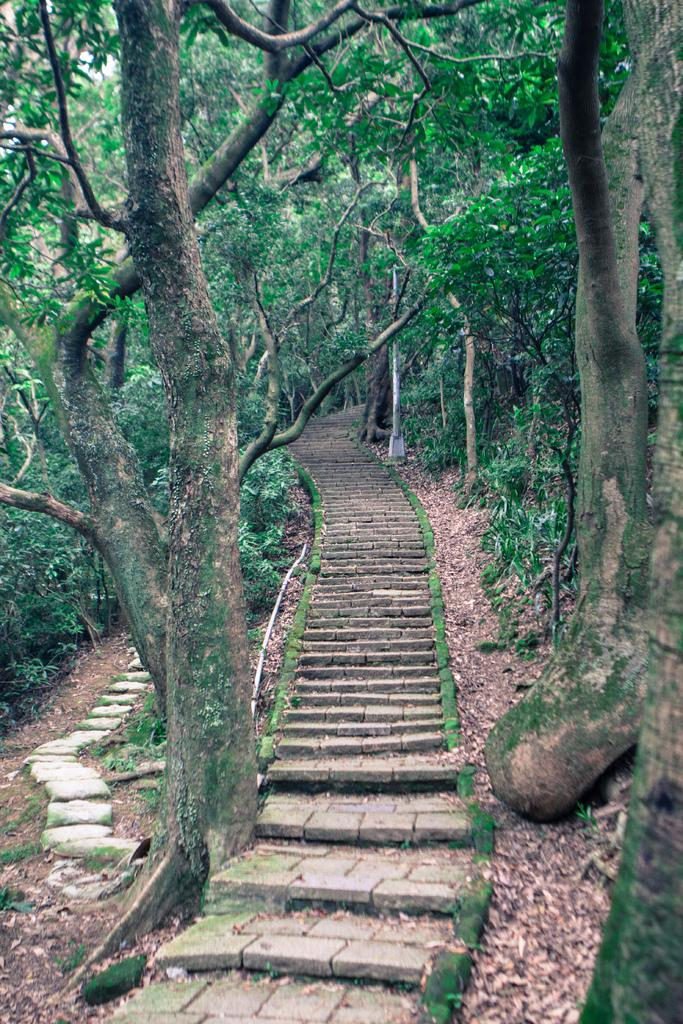What is the main structure in the center of the image? There is a staircase in the center of the image. What type of material can be seen on the ground in the image? Stones are visible in the image. What part of the trees is present in the image? The bark of trees is present in the image. What object can be seen standing upright in the image? There is a pole in the image. What type of plant material is visible on the ground in the image? Dried leaves are visible in the image. How many trees are present in the image? A group of trees is present in the image. How many pizzas are being served on the linen tablecloth in the image? There are no pizzas or linen tablecloth present in the image; it features a staircase, stones, tree bark, a pole, dried leaves, and a group of trees. 